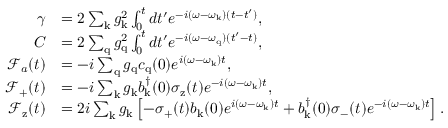Convert formula to latex. <formula><loc_0><loc_0><loc_500><loc_500>\begin{array} { r l } { \gamma } & { = 2 \sum _ { k } g _ { k } ^ { 2 } \int _ { 0 } ^ { t } d t ^ { \prime } e ^ { - i ( \omega - \omega _ { k } ) ( t - t ^ { \prime } ) } , } \\ { C } & { = 2 \sum _ { q } g _ { q } ^ { 2 } \int _ { 0 } ^ { t } d t ^ { \prime } e ^ { - i ( \omega - \omega _ { q } ) ( t ^ { \prime } - t ) } , } \\ { \mathcal { F } _ { a } ( t ) } & { = - i \sum _ { q } g _ { q } c _ { q } ( 0 ) e ^ { i ( \omega - \omega _ { k } ) t } , } \\ { \mathcal { F } _ { + } ( t ) } & { = - i \sum _ { k } g _ { k } b _ { k } ^ { \dagger } ( 0 ) \sigma _ { z } ( t ) e ^ { - i ( \omega - \omega _ { k } ) t } , } \\ { \mathcal { F } _ { z } ( t ) } & { = 2 i \sum _ { k } g _ { k } \left [ - \sigma _ { + } ( t ) b _ { k } ( 0 ) e ^ { i ( \omega - \omega _ { k } ) t } + b _ { k } ^ { \dagger } ( 0 ) \sigma _ { - } ( t ) e ^ { - i ( \omega - \omega _ { k } ) t } \right ] . } \end{array}</formula> 